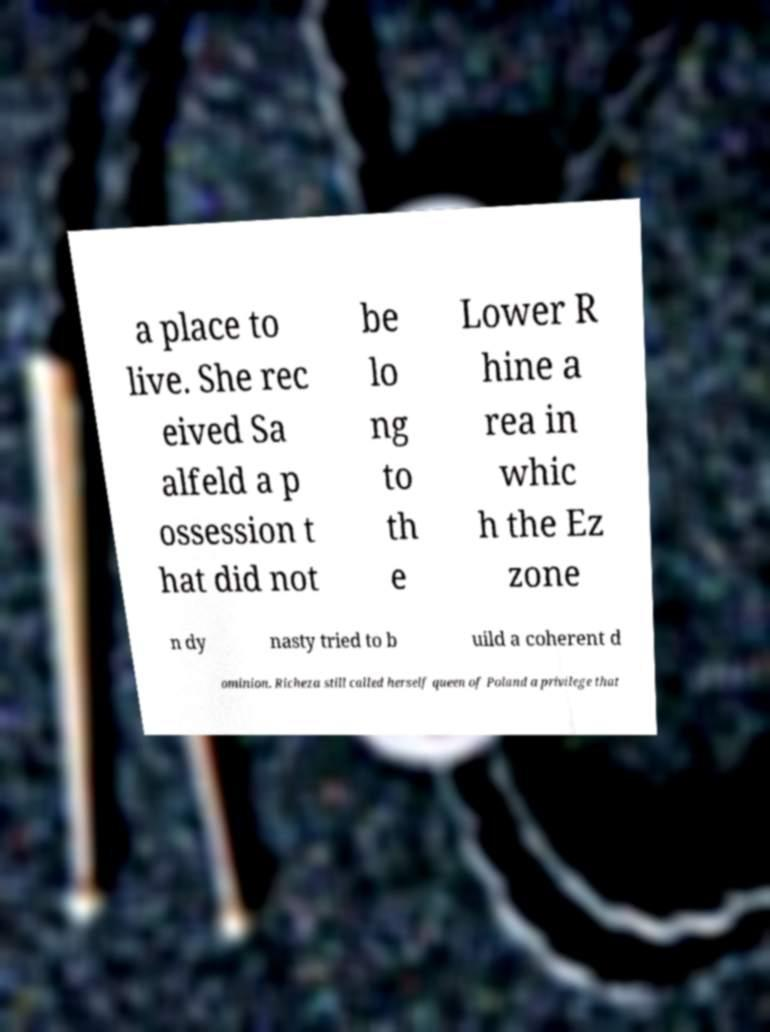For documentation purposes, I need the text within this image transcribed. Could you provide that? a place to live. She rec eived Sa alfeld a p ossession t hat did not be lo ng to th e Lower R hine a rea in whic h the Ez zone n dy nasty tried to b uild a coherent d ominion. Richeza still called herself queen of Poland a privilege that 